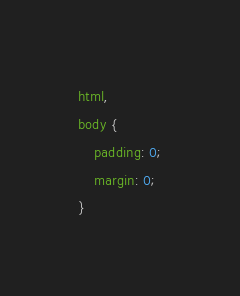Convert code to text. <code><loc_0><loc_0><loc_500><loc_500><_CSS_>html,
body {
    padding: 0;
    margin: 0;
}</code> 